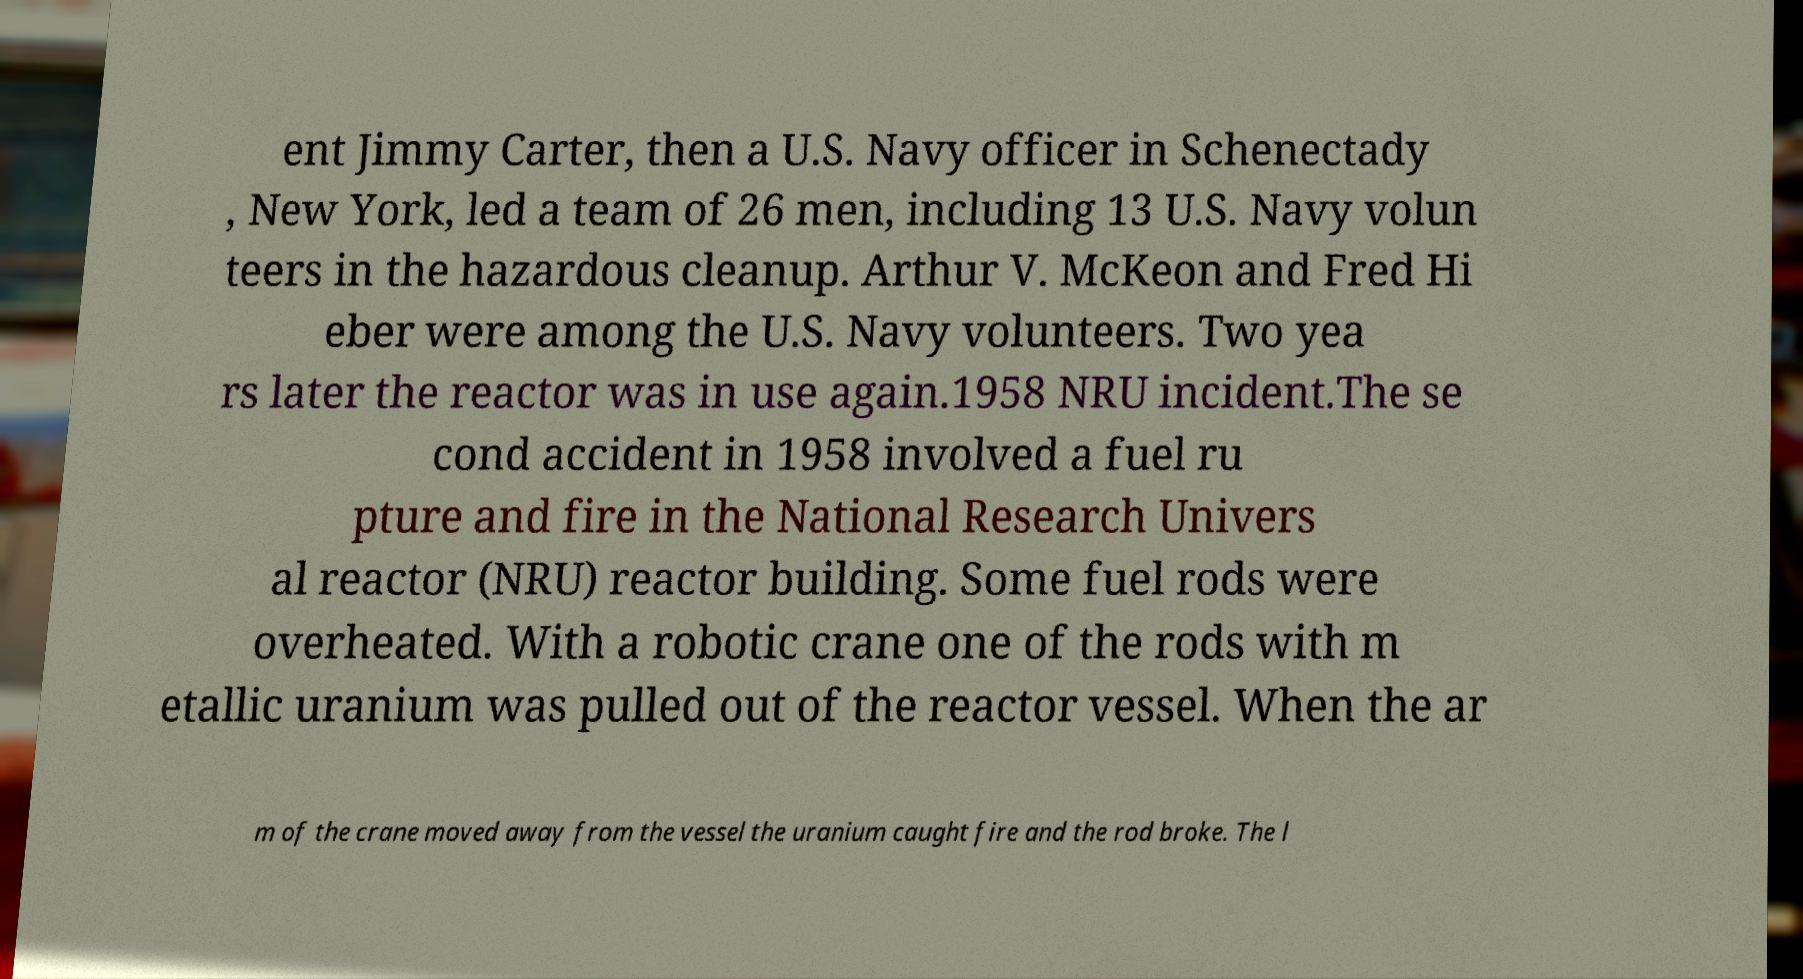Could you extract and type out the text from this image? ent Jimmy Carter, then a U.S. Navy officer in Schenectady , New York, led a team of 26 men, including 13 U.S. Navy volun teers in the hazardous cleanup. Arthur V. McKeon and Fred Hi eber were among the U.S. Navy volunteers. Two yea rs later the reactor was in use again.1958 NRU incident.The se cond accident in 1958 involved a fuel ru pture and fire in the National Research Univers al reactor (NRU) reactor building. Some fuel rods were overheated. With a robotic crane one of the rods with m etallic uranium was pulled out of the reactor vessel. When the ar m of the crane moved away from the vessel the uranium caught fire and the rod broke. The l 